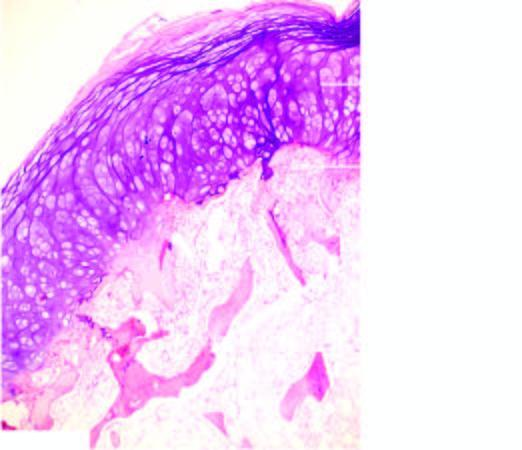does periphery show mature cartilage cells covering the underlying mature lamellar bone containing marrow spaces?
Answer the question using a single word or phrase. No 